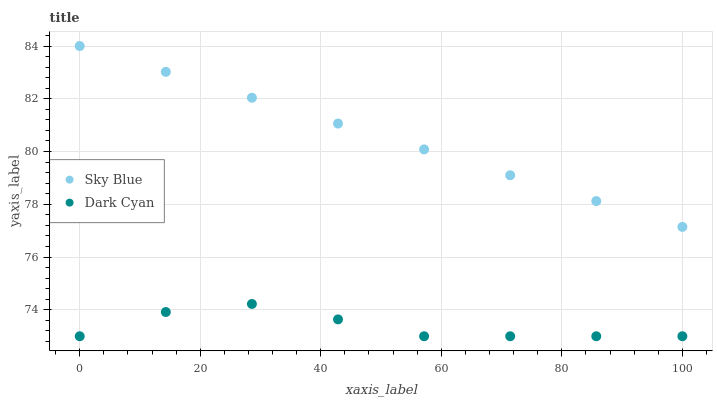Does Dark Cyan have the minimum area under the curve?
Answer yes or no. Yes. Does Sky Blue have the maximum area under the curve?
Answer yes or no. Yes. Does Sky Blue have the minimum area under the curve?
Answer yes or no. No. Is Sky Blue the smoothest?
Answer yes or no. Yes. Is Dark Cyan the roughest?
Answer yes or no. Yes. Is Sky Blue the roughest?
Answer yes or no. No. Does Dark Cyan have the lowest value?
Answer yes or no. Yes. Does Sky Blue have the lowest value?
Answer yes or no. No. Does Sky Blue have the highest value?
Answer yes or no. Yes. Is Dark Cyan less than Sky Blue?
Answer yes or no. Yes. Is Sky Blue greater than Dark Cyan?
Answer yes or no. Yes. Does Dark Cyan intersect Sky Blue?
Answer yes or no. No. 